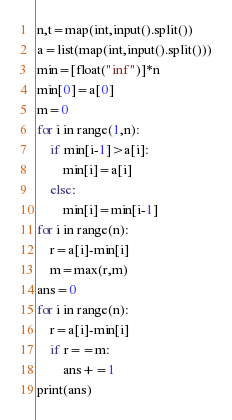Convert code to text. <code><loc_0><loc_0><loc_500><loc_500><_Python_>n,t=map(int,input().split())
a=list(map(int,input().split()))
min=[float("inf")]*n
min[0]=a[0]
m=0
for i in range(1,n):
    if min[i-1]>a[i]:
        min[i]=a[i]
    else:
        min[i]=min[i-1]
for i in range(n):
    r=a[i]-min[i]
    m=max(r,m)
ans=0
for i in range(n):
    r=a[i]-min[i]
    if r==m:
        ans+=1
print(ans)
</code> 